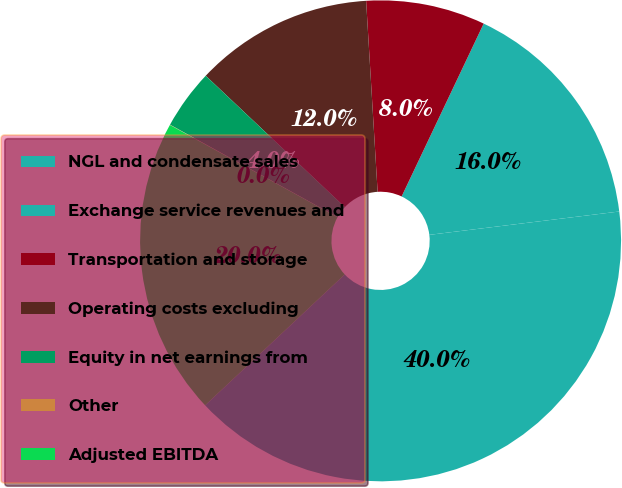<chart> <loc_0><loc_0><loc_500><loc_500><pie_chart><fcel>NGL and condensate sales<fcel>Exchange service revenues and<fcel>Transportation and storage<fcel>Operating costs excluding<fcel>Equity in net earnings from<fcel>Other<fcel>Adjusted EBITDA<nl><fcel>39.96%<fcel>16.0%<fcel>8.01%<fcel>12.0%<fcel>4.02%<fcel>0.02%<fcel>19.99%<nl></chart> 